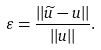Convert formula to latex. <formula><loc_0><loc_0><loc_500><loc_500>\varepsilon = \frac { | | \widetilde { u } - u | | } { | | u | | } .</formula> 